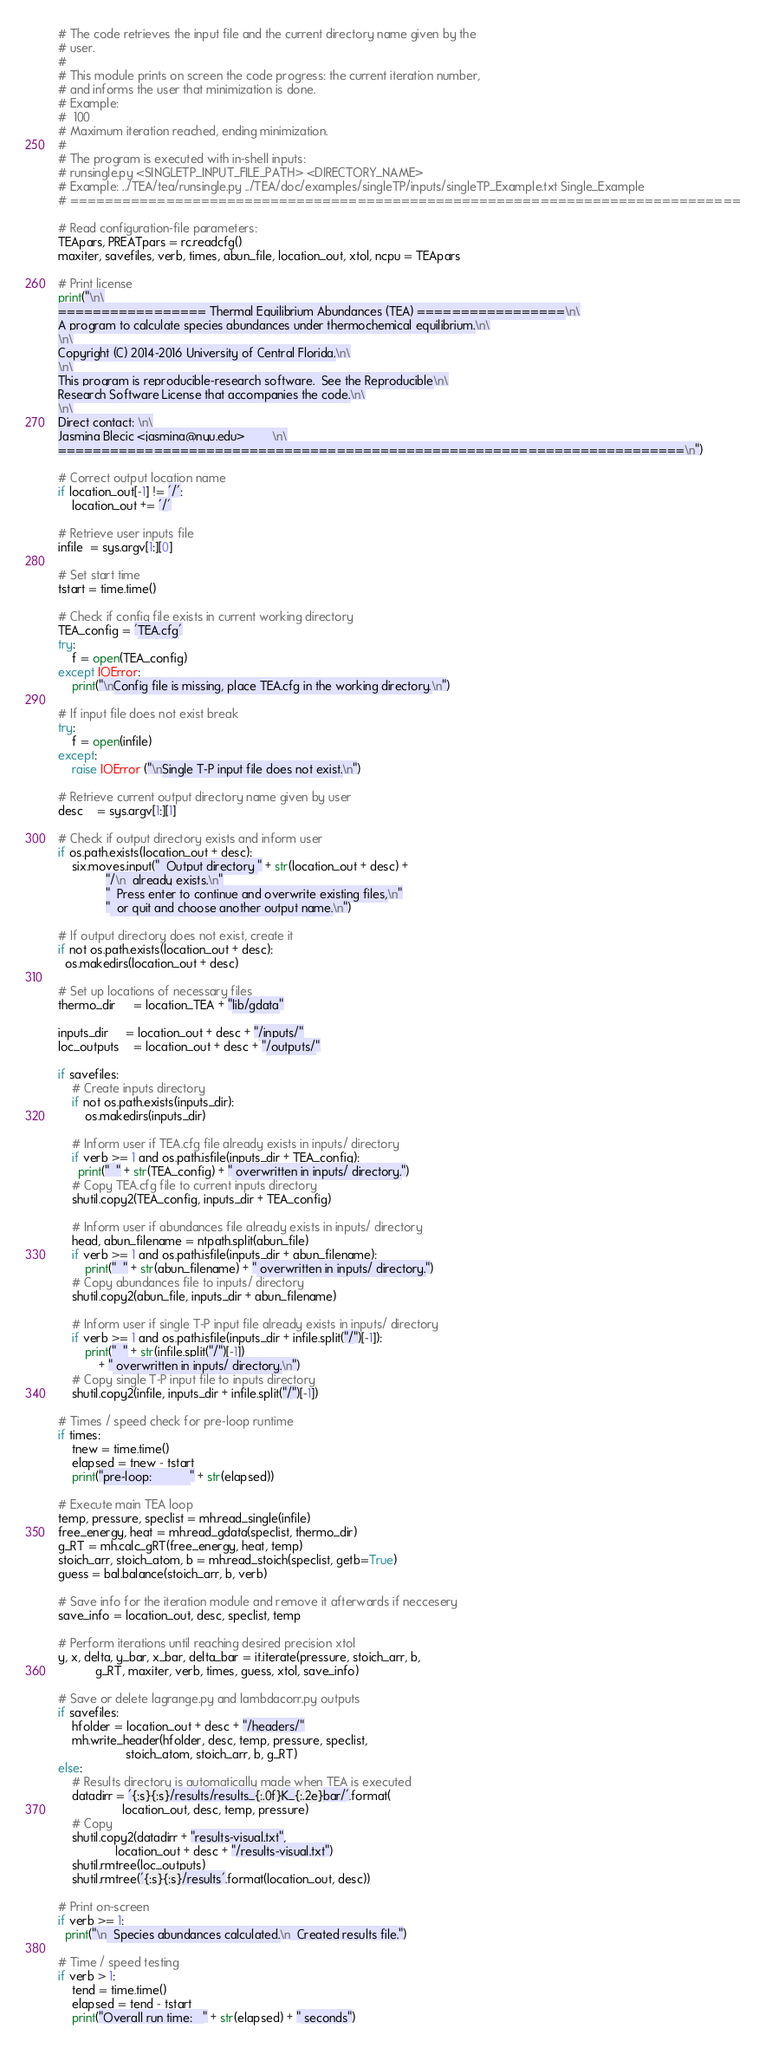Convert code to text. <code><loc_0><loc_0><loc_500><loc_500><_Python_># The code retrieves the input file and the current directory name given by the
# user. 
#
# This module prints on screen the code progress: the current iteration number, 
# and informs the user that minimization is done.
# Example:
#  100
# Maximum iteration reached, ending minimization.
#
# The program is executed with in-shell inputs:
# runsingle.py <SINGLETP_INPUT_FILE_PATH> <DIRECTORY_NAME>
# Example: ../TEA/tea/runsingle.py ../TEA/doc/examples/singleTP/inputs/singleTP_Example.txt Single_Example
# =============================================================================

# Read configuration-file parameters:
TEApars, PREATpars = rc.readcfg()
maxiter, savefiles, verb, times, abun_file, location_out, xtol, ncpu = TEApars

# Print license
print("\n\
================= Thermal Equilibrium Abundances (TEA) =================\n\
A program to calculate species abundances under thermochemical equilibrium.\n\
\n\
Copyright (C) 2014-2016 University of Central Florida.\n\
\n\
This program is reproducible-research software.  See the Reproducible\n\
Research Software License that accompanies the code.\n\
\n\
Direct contact: \n\
Jasmina Blecic <jasmina@nyu.edu>        \n\
========================================================================\n")

# Correct output location name
if location_out[-1] != '/':
    location_out += '/'

# Retrieve user inputs file
infile  = sys.argv[1:][0]

# Set start time
tstart = time.time()

# Check if config file exists in current working directory
TEA_config = 'TEA.cfg'
try:
    f = open(TEA_config)
except IOError:
    print("\nConfig file is missing, place TEA.cfg in the working directory.\n")

# If input file does not exist break
try:
    f = open(infile)
except:
    raise IOError ("\nSingle T-P input file does not exist.\n")

# Retrieve current output directory name given by user
desc    = sys.argv[1:][1]

# Check if output directory exists and inform user
if os.path.exists(location_out + desc):
    six.moves.input("  Output directory " + str(location_out + desc) +  
              "/\n  already exists.\n"
              "  Press enter to continue and overwrite existing files,\n"
              "  or quit and choose another output name.\n")

# If output directory does not exist, create it
if not os.path.exists(location_out + desc):
  os.makedirs(location_out + desc)

# Set up locations of necessary files
thermo_dir     = location_TEA + "lib/gdata"

inputs_dir     = location_out + desc + "/inputs/"
loc_outputs    = location_out + desc + "/outputs/"

if savefiles:
    # Create inputs directory
    if not os.path.exists(inputs_dir):
        os.makedirs(inputs_dir)

    # Inform user if TEA.cfg file already exists in inputs/ directory
    if verb >= 1 and os.path.isfile(inputs_dir + TEA_config):
      print("  " + str(TEA_config) + " overwritten in inputs/ directory.")
    # Copy TEA.cfg file to current inputs directory
    shutil.copy2(TEA_config, inputs_dir + TEA_config)

    # Inform user if abundances file already exists in inputs/ directory
    head, abun_filename = ntpath.split(abun_file)
    if verb >= 1 and os.path.isfile(inputs_dir + abun_filename):
        print("  " + str(abun_filename) + " overwritten in inputs/ directory.")
    # Copy abundances file to inputs/ directory
    shutil.copy2(abun_file, inputs_dir + abun_filename)

    # Inform user if single T-P input file already exists in inputs/ directory
    if verb >= 1 and os.path.isfile(inputs_dir + infile.split("/")[-1]):
        print("  " + str(infile.split("/")[-1])
            + " overwritten in inputs/ directory.\n")
    # Copy single T-P input file to inputs directory
    shutil.copy2(infile, inputs_dir + infile.split("/")[-1])

# Times / speed check for pre-loop runtime
if times:
    tnew = time.time()
    elapsed = tnew - tstart
    print("pre-loop:           " + str(elapsed))

# Execute main TEA loop
temp, pressure, speclist = mh.read_single(infile)
free_energy, heat = mh.read_gdata(speclist, thermo_dir)
g_RT = mh.calc_gRT(free_energy, heat, temp)
stoich_arr, stoich_atom, b = mh.read_stoich(speclist, getb=True)
guess = bal.balance(stoich_arr, b, verb)

# Save info for the iteration module and remove it afterwards if neccesery
save_info = location_out, desc, speclist, temp    

# Perform iterations until reaching desired precision xtol
y, x, delta, y_bar, x_bar, delta_bar = it.iterate(pressure, stoich_arr, b,
           g_RT, maxiter, verb, times, guess, xtol, save_info)

# Save or delete lagrange.py and lambdacorr.py outputs
if savefiles:
    hfolder = location_out + desc + "/headers/"
    mh.write_header(hfolder, desc, temp, pressure, speclist,
                    stoich_atom, stoich_arr, b, g_RT)
else:
    # Results directory is automatically made when TEA is executed
    datadirr = '{:s}{:s}/results/results_{:.0f}K_{:.2e}bar/'.format(
                   location_out, desc, temp, pressure)
    # Copy
    shutil.copy2(datadirr + "results-visual.txt",
                 location_out + desc + "/results-visual.txt")
    shutil.rmtree(loc_outputs)
    shutil.rmtree('{:s}{:s}/results'.format(location_out, desc))

# Print on-screen
if verb >= 1:
  print("\n  Species abundances calculated.\n  Created results file.")

# Time / speed testing
if verb > 1:
    tend = time.time()
    elapsed = tend - tstart
    print("Overall run time:   " + str(elapsed) + " seconds")


</code> 